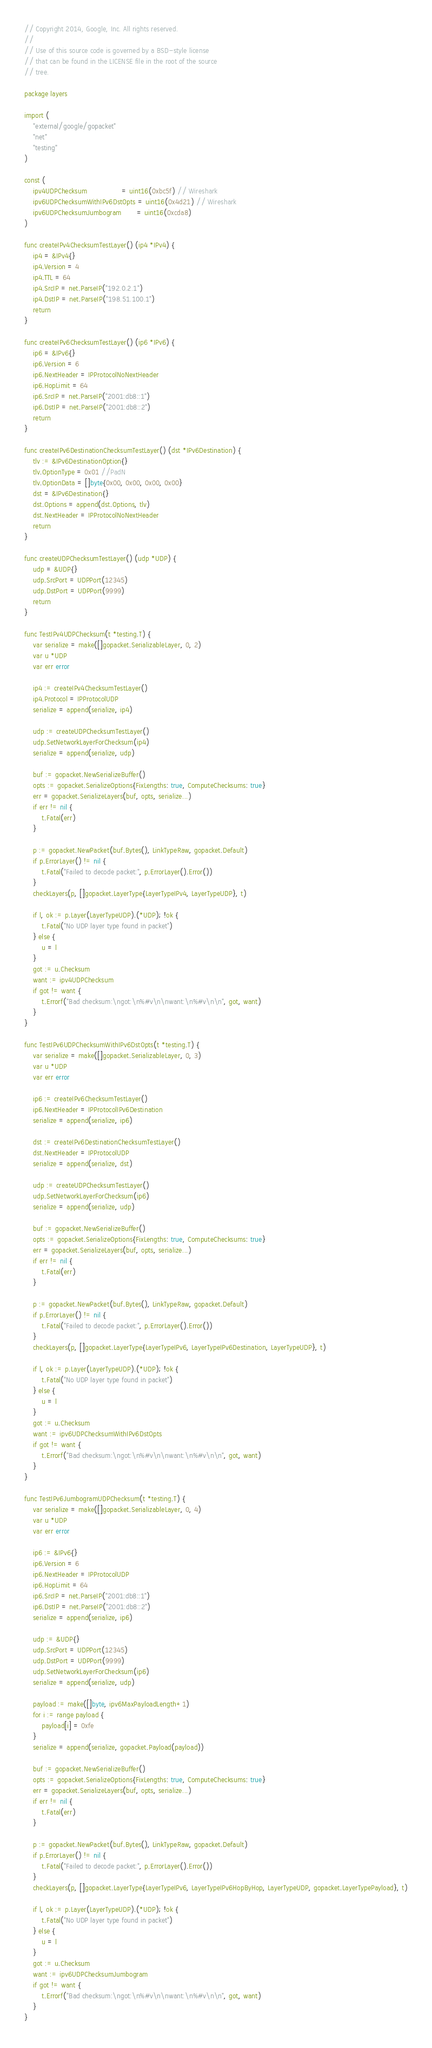<code> <loc_0><loc_0><loc_500><loc_500><_Go_>// Copyright 2014, Google, Inc. All rights reserved.
//
// Use of this source code is governed by a BSD-style license
// that can be found in the LICENSE file in the root of the source
// tree.

package layers

import (
	"external/google/gopacket"
	"net"
	"testing"
)

const (
	ipv4UDPChecksum                = uint16(0xbc5f) // Wireshark
	ipv6UDPChecksumWithIPv6DstOpts = uint16(0x4d21) // Wireshark
	ipv6UDPChecksumJumbogram       = uint16(0xcda8)
)

func createIPv4ChecksumTestLayer() (ip4 *IPv4) {
	ip4 = &IPv4{}
	ip4.Version = 4
	ip4.TTL = 64
	ip4.SrcIP = net.ParseIP("192.0.2.1")
	ip4.DstIP = net.ParseIP("198.51.100.1")
	return
}

func createIPv6ChecksumTestLayer() (ip6 *IPv6) {
	ip6 = &IPv6{}
	ip6.Version = 6
	ip6.NextHeader = IPProtocolNoNextHeader
	ip6.HopLimit = 64
	ip6.SrcIP = net.ParseIP("2001:db8::1")
	ip6.DstIP = net.ParseIP("2001:db8::2")
	return
}

func createIPv6DestinationChecksumTestLayer() (dst *IPv6Destination) {
	tlv := &IPv6DestinationOption{}
	tlv.OptionType = 0x01 //PadN
	tlv.OptionData = []byte{0x00, 0x00, 0x00, 0x00}
	dst = &IPv6Destination{}
	dst.Options = append(dst.Options, tlv)
	dst.NextHeader = IPProtocolNoNextHeader
	return
}

func createUDPChecksumTestLayer() (udp *UDP) {
	udp = &UDP{}
	udp.SrcPort = UDPPort(12345)
	udp.DstPort = UDPPort(9999)
	return
}

func TestIPv4UDPChecksum(t *testing.T) {
	var serialize = make([]gopacket.SerializableLayer, 0, 2)
	var u *UDP
	var err error

	ip4 := createIPv4ChecksumTestLayer()
	ip4.Protocol = IPProtocolUDP
	serialize = append(serialize, ip4)

	udp := createUDPChecksumTestLayer()
	udp.SetNetworkLayerForChecksum(ip4)
	serialize = append(serialize, udp)

	buf := gopacket.NewSerializeBuffer()
	opts := gopacket.SerializeOptions{FixLengths: true, ComputeChecksums: true}
	err = gopacket.SerializeLayers(buf, opts, serialize...)
	if err != nil {
		t.Fatal(err)
	}

	p := gopacket.NewPacket(buf.Bytes(), LinkTypeRaw, gopacket.Default)
	if p.ErrorLayer() != nil {
		t.Fatal("Failed to decode packet:", p.ErrorLayer().Error())
	}
	checkLayers(p, []gopacket.LayerType{LayerTypeIPv4, LayerTypeUDP}, t)

	if l, ok := p.Layer(LayerTypeUDP).(*UDP); !ok {
		t.Fatal("No UDP layer type found in packet")
	} else {
		u = l
	}
	got := u.Checksum
	want := ipv4UDPChecksum
	if got != want {
		t.Errorf("Bad checksum:\ngot:\n%#v\n\nwant:\n%#v\n\n", got, want)
	}
}

func TestIPv6UDPChecksumWithIPv6DstOpts(t *testing.T) {
	var serialize = make([]gopacket.SerializableLayer, 0, 3)
	var u *UDP
	var err error

	ip6 := createIPv6ChecksumTestLayer()
	ip6.NextHeader = IPProtocolIPv6Destination
	serialize = append(serialize, ip6)

	dst := createIPv6DestinationChecksumTestLayer()
	dst.NextHeader = IPProtocolUDP
	serialize = append(serialize, dst)

	udp := createUDPChecksumTestLayer()
	udp.SetNetworkLayerForChecksum(ip6)
	serialize = append(serialize, udp)

	buf := gopacket.NewSerializeBuffer()
	opts := gopacket.SerializeOptions{FixLengths: true, ComputeChecksums: true}
	err = gopacket.SerializeLayers(buf, opts, serialize...)
	if err != nil {
		t.Fatal(err)
	}

	p := gopacket.NewPacket(buf.Bytes(), LinkTypeRaw, gopacket.Default)
	if p.ErrorLayer() != nil {
		t.Fatal("Failed to decode packet:", p.ErrorLayer().Error())
	}
	checkLayers(p, []gopacket.LayerType{LayerTypeIPv6, LayerTypeIPv6Destination, LayerTypeUDP}, t)

	if l, ok := p.Layer(LayerTypeUDP).(*UDP); !ok {
		t.Fatal("No UDP layer type found in packet")
	} else {
		u = l
	}
	got := u.Checksum
	want := ipv6UDPChecksumWithIPv6DstOpts
	if got != want {
		t.Errorf("Bad checksum:\ngot:\n%#v\n\nwant:\n%#v\n\n", got, want)
	}
}

func TestIPv6JumbogramUDPChecksum(t *testing.T) {
	var serialize = make([]gopacket.SerializableLayer, 0, 4)
	var u *UDP
	var err error

	ip6 := &IPv6{}
	ip6.Version = 6
	ip6.NextHeader = IPProtocolUDP
	ip6.HopLimit = 64
	ip6.SrcIP = net.ParseIP("2001:db8::1")
	ip6.DstIP = net.ParseIP("2001:db8::2")
	serialize = append(serialize, ip6)

	udp := &UDP{}
	udp.SrcPort = UDPPort(12345)
	udp.DstPort = UDPPort(9999)
	udp.SetNetworkLayerForChecksum(ip6)
	serialize = append(serialize, udp)

	payload := make([]byte, ipv6MaxPayloadLength+1)
	for i := range payload {
		payload[i] = 0xfe
	}
	serialize = append(serialize, gopacket.Payload(payload))

	buf := gopacket.NewSerializeBuffer()
	opts := gopacket.SerializeOptions{FixLengths: true, ComputeChecksums: true}
	err = gopacket.SerializeLayers(buf, opts, serialize...)
	if err != nil {
		t.Fatal(err)
	}

	p := gopacket.NewPacket(buf.Bytes(), LinkTypeRaw, gopacket.Default)
	if p.ErrorLayer() != nil {
		t.Fatal("Failed to decode packet:", p.ErrorLayer().Error())
	}
	checkLayers(p, []gopacket.LayerType{LayerTypeIPv6, LayerTypeIPv6HopByHop, LayerTypeUDP, gopacket.LayerTypePayload}, t)

	if l, ok := p.Layer(LayerTypeUDP).(*UDP); !ok {
		t.Fatal("No UDP layer type found in packet")
	} else {
		u = l
	}
	got := u.Checksum
	want := ipv6UDPChecksumJumbogram
	if got != want {
		t.Errorf("Bad checksum:\ngot:\n%#v\n\nwant:\n%#v\n\n", got, want)
	}
}
</code> 